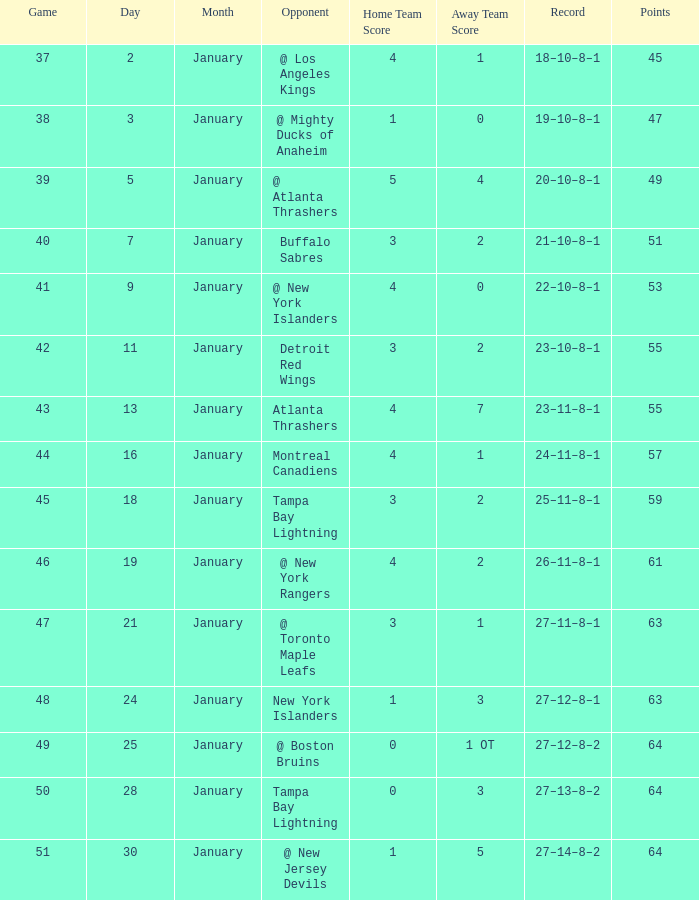How many Points have a January of 18? 1.0. 